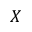<formula> <loc_0><loc_0><loc_500><loc_500>X</formula> 